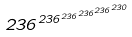<formula> <loc_0><loc_0><loc_500><loc_500>2 3 6 ^ { 2 3 6 ^ { 2 3 6 ^ { 2 3 6 ^ { 2 3 6 ^ { 2 3 0 } } } } }</formula> 